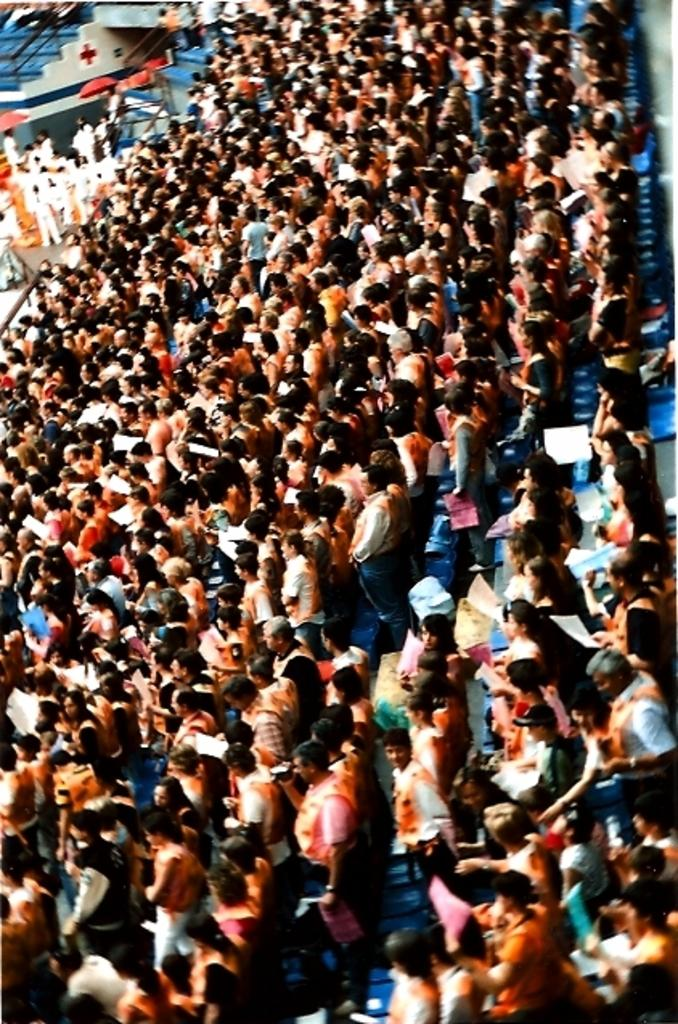What are the people in the image doing? The people in the image are sitting on chairs. Can you describe the gender of the people in the image? There are men and women in the image. What type of polish is being applied to the cub in the image? There is no cub or polish present in the image; it only features people sitting on chairs. 